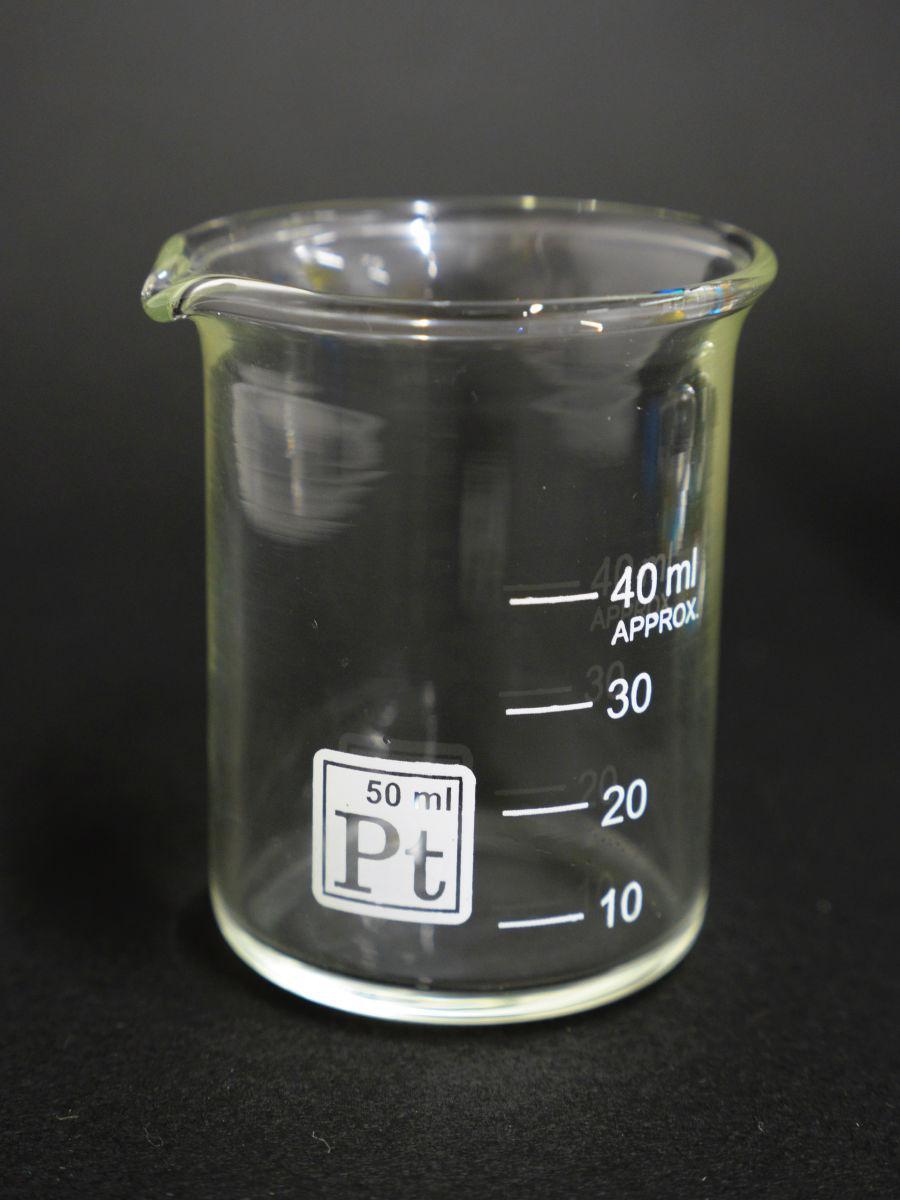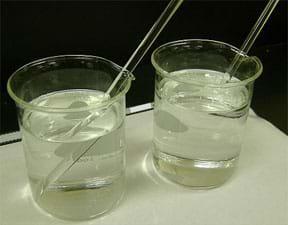The first image is the image on the left, the second image is the image on the right. Examine the images to the left and right. Is the description "There are four measuring glasses." accurate? Answer yes or no. No. The first image is the image on the left, the second image is the image on the right. Examine the images to the left and right. Is the description "There are four beakers in total." accurate? Answer yes or no. No. 